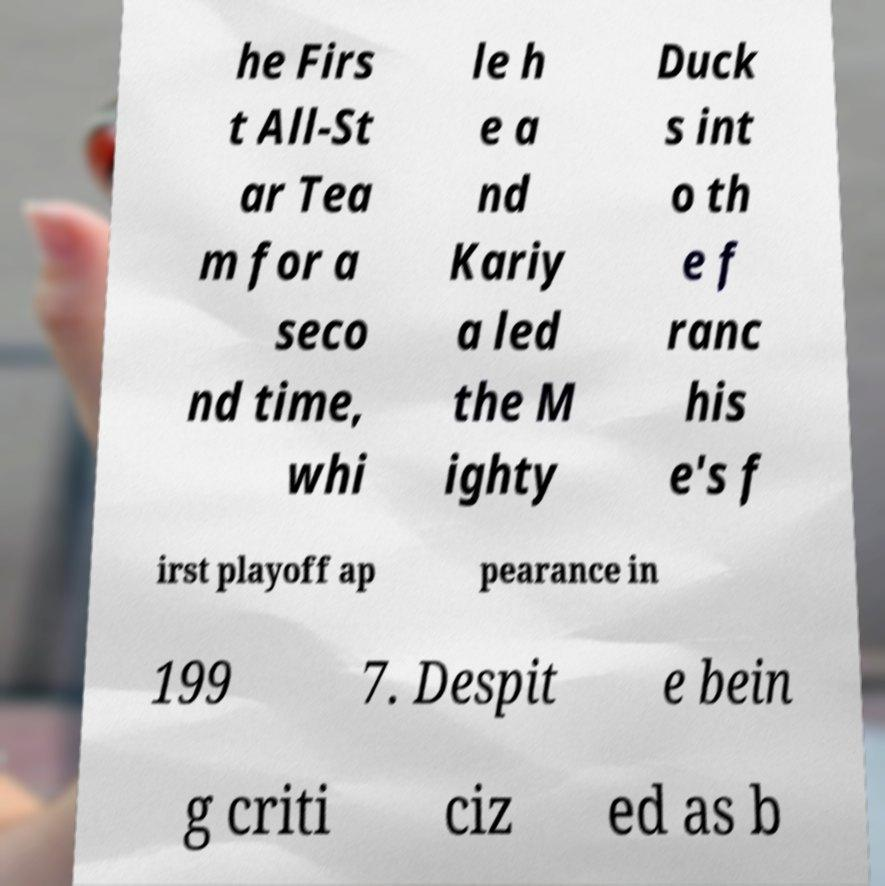What messages or text are displayed in this image? I need them in a readable, typed format. he Firs t All-St ar Tea m for a seco nd time, whi le h e a nd Kariy a led the M ighty Duck s int o th e f ranc his e's f irst playoff ap pearance in 199 7. Despit e bein g criti ciz ed as b 